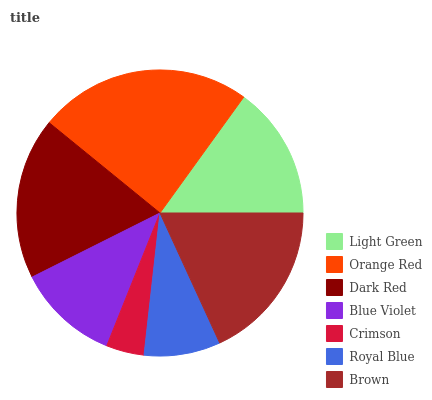Is Crimson the minimum?
Answer yes or no. Yes. Is Orange Red the maximum?
Answer yes or no. Yes. Is Dark Red the minimum?
Answer yes or no. No. Is Dark Red the maximum?
Answer yes or no. No. Is Orange Red greater than Dark Red?
Answer yes or no. Yes. Is Dark Red less than Orange Red?
Answer yes or no. Yes. Is Dark Red greater than Orange Red?
Answer yes or no. No. Is Orange Red less than Dark Red?
Answer yes or no. No. Is Light Green the high median?
Answer yes or no. Yes. Is Light Green the low median?
Answer yes or no. Yes. Is Orange Red the high median?
Answer yes or no. No. Is Dark Red the low median?
Answer yes or no. No. 